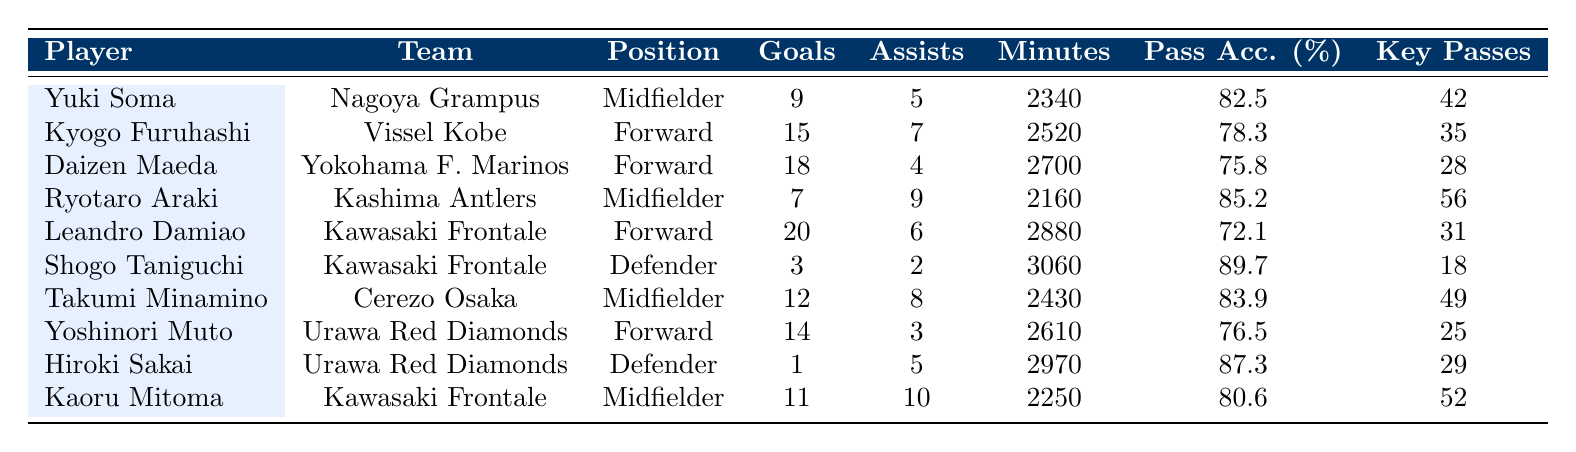What is the total number of goals scored by Leandro Damiao? Leandro Damiao is listed with 20 goals in the table, so to find his total goals, we directly refer to the number against his name.
Answer: 20 Which player had the highest pass accuracy? By reviewing the pass accuracy column, Shogo Taniguchi is shown with a pass accuracy of 89.7%, which is the highest when compared to other players.
Answer: 89.7 How many assists did Takumi Minamino contribute? Looking for Takumi Minamino in the table, we see he has 8 assists listed, which is directly taken from the assists column in his row.
Answer: 8 What is the average number of yellow cards among the players listed? To calculate the average, we first find the yellow cards for each player: 3, 2, 4, 5, 3, 6, 2, 4, 7, 1. Summing these values gives us 37 yellow cards total. There are 10 players, so the average is 37/10 = 3.7.
Answer: 3.7 Did any player receive a red card? Checking the data, only Daizen Maeda and Hiroki Sakai have received red cards (1 each), while others have a count of 0, confirming that at least some players did receive red cards.
Answer: Yes Who scored the most goals among midfielders? Among midfielders, we have Yuki Soma with 9 goals, Ryotaro Araki with 7 goals, and Takumi Minamino with 12 goals. Since 12 is the highest, Takumi Minamino ranks as the top goal-scorer among midfielders.
Answer: Takumi Minamino What is the total number of key passes for all forwards combined? The forwards listed are Kyogo Furuhashi (35 key passes), Daizen Maeda (28 key passes), Leandro Damiao (31 key passes), and Yoshinori Muto (25 key passes). Summing these gives us 35 + 28 + 31 + 25 = 119 key passes total for forwards.
Answer: 119 Which player played the most minutes in the J1 League 2022 season? By comparing the minutes played for each player, Shogo Taniguchi has the highest at 3060 minutes, which can be identified in the minutes played column.
Answer: 3060 How many goals and assists did Daizen Maeda have combined? Daizen Maeda scored 18 goals and provided 4 assists. Combining these, we add them together: 18 + 4 = 22, giving us the total combined contributions.
Answer: 22 Who had a higher shooting accuracy: Yuki Soma or Takumi Minamino? Directly comparing the shots on target for Yuki Soma (28) with those of Takumi Minamino (38), Takumi Minamino scored higher; thus, he had a better shooting performance in terms of shots on target.
Answer: Takumi Minamino 